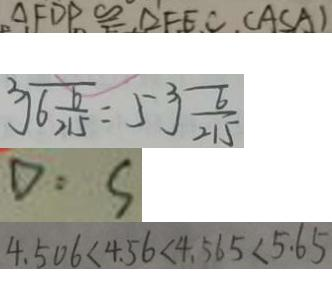<formula> <loc_0><loc_0><loc_500><loc_500>\Delta F D P \cong \Delta F E C . ( A S A ) 
 \sqrt [ 3 ] { 6 \frac { 6 } { 2 1 5 } } = 5 \sqrt [ 3 ] { \frac { 6 } { 2 1 5 } } 
 D : S 
 4 . 5 0 6 < 4 . 5 6 < 4 . 5 6 5 < 5 . 6 5</formula> 